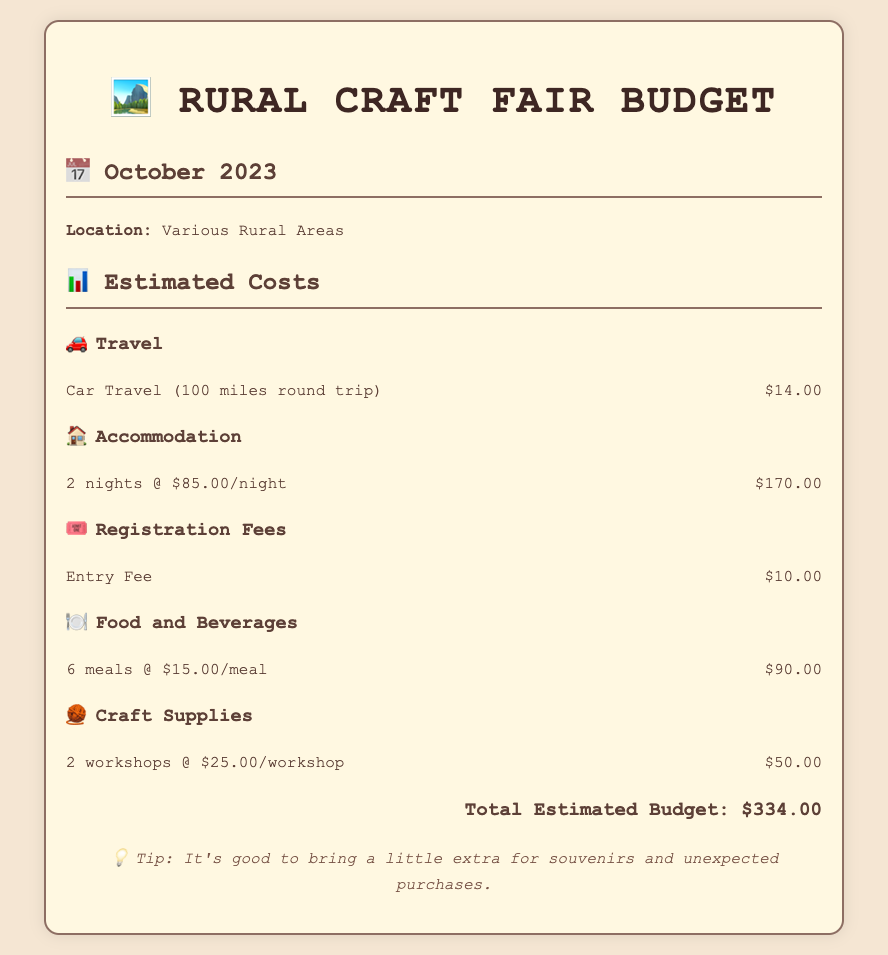what is the budget for travel? The travel budget is specified under the travel section as $14.00.
Answer: $14.00 how many nights will the accommodation cost? The accommodation section states that it covers 2 nights at $85.00 each.
Answer: 2 nights what is the registration fee for the craft fair? The registration fee is mentioned as the entry fee in the registration fees section, which is $10.00.
Answer: $10.00 how much is allocated for food and beverages? The food and beverages section lists 6 meals at $15.00 each, totaling to $90.00.
Answer: $90.00 what is the total estimated budget for the event? The total estimated budget is calculated by summing all expense categories, which comes to $334.00.
Answer: $334.00 how many workshops will be attended? The document specifies that 2 workshops will be attended at $25.00 each.
Answer: 2 workshops what is the cost per meal listed in the budget? The cost per meal is defined in the food and beverages section as $15.00.
Answer: $15.00 what is the purpose of the extra budget tip provided? The tip suggests bringing additional money for souvenirs and unforeseen expenses during the event.
Answer: Souvenirs and unexpected purchases 